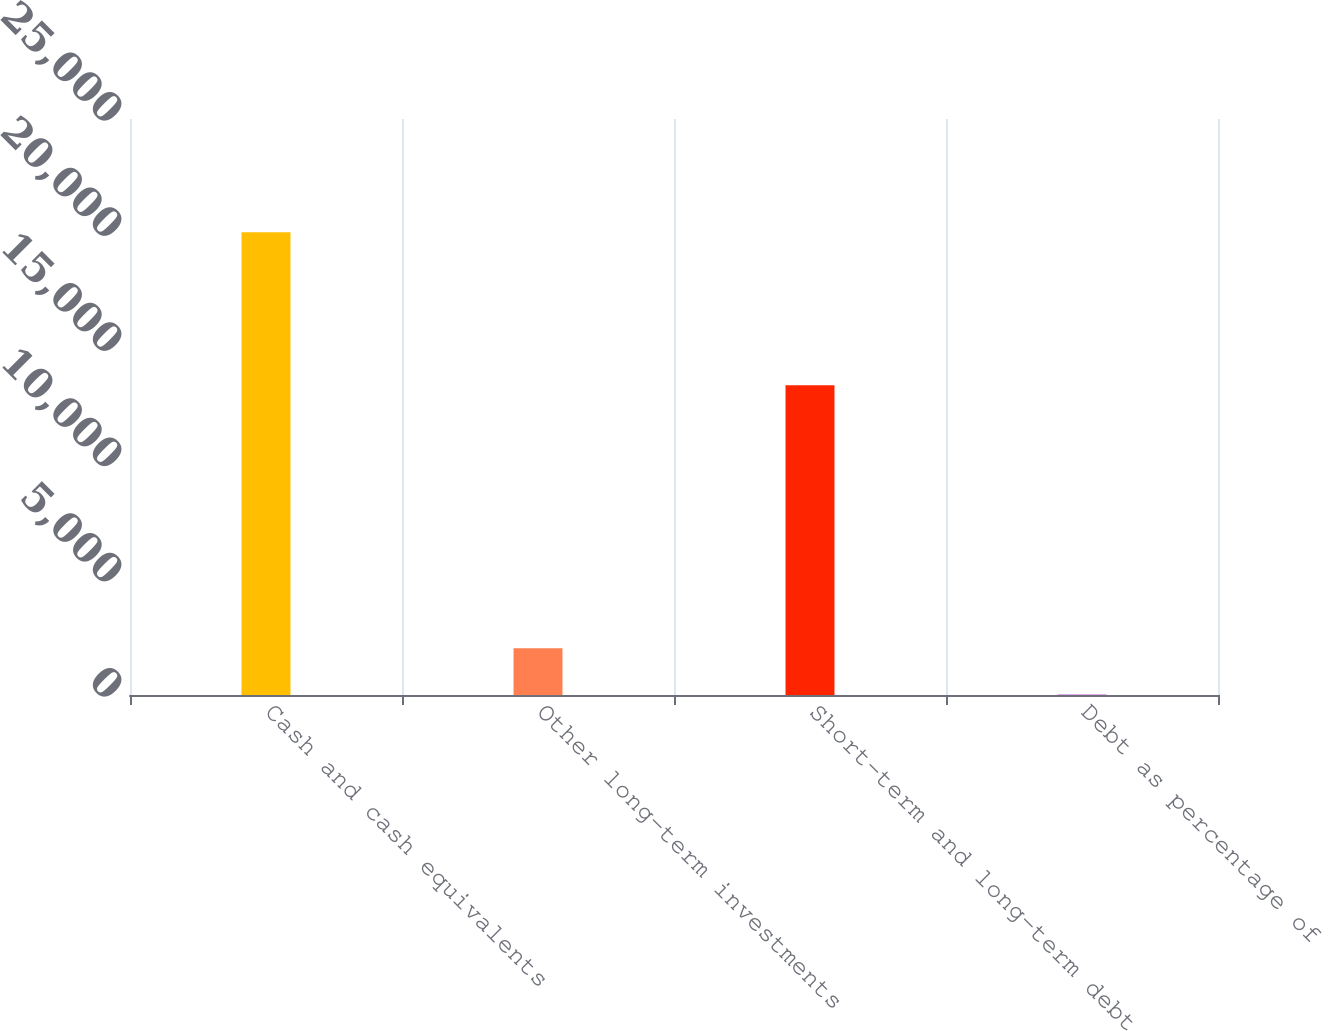Convert chart to OTSL. <chart><loc_0><loc_0><loc_500><loc_500><bar_chart><fcel>Cash and cash equivalents<fcel>Other long-term investments<fcel>Short-term and long-term debt<fcel>Debt as percentage of<nl><fcel>20087<fcel>2029.49<fcel>13446<fcel>23.1<nl></chart> 